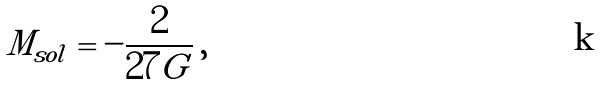<formula> <loc_0><loc_0><loc_500><loc_500>M _ { s o l } = - \frac { 2 } { 2 7 G } \, ,</formula> 